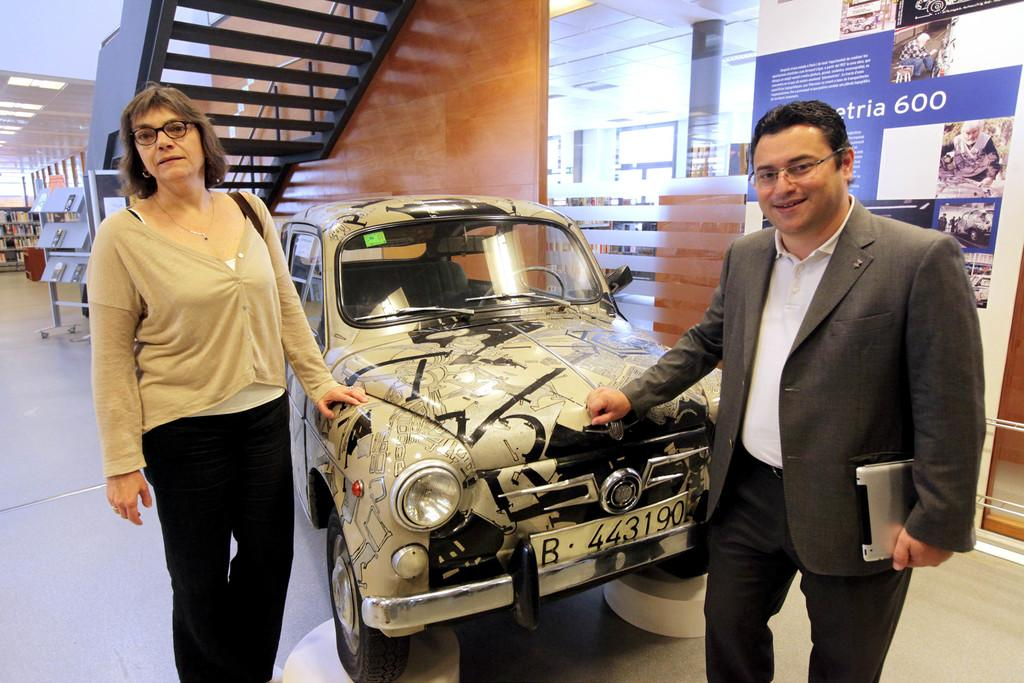What is the main subject in the middle of the image? There is a car in the middle of the image. Who is present beside the car? There is a man and a woman beside the car. What are the man and the woman wearing? The man and the woman are wearing spectacles. What can be seen in the background of the image? There is a hoarding, glass, books, and lights visible in the background of the image. Is the car being driven by the man and the woman in the image? The image does not show the car being driven; it only shows the man and the woman standing beside it. Can you see any signs of the books burning in the background of the image? There is no indication of any burning or fire in the image, and the books are not shown to be burning. 